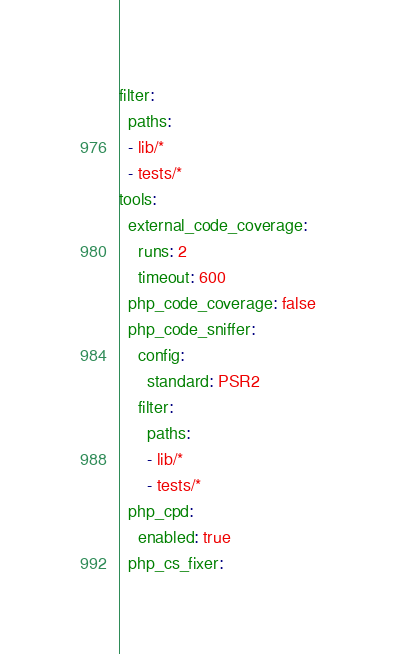Convert code to text. <code><loc_0><loc_0><loc_500><loc_500><_YAML_>filter:
  paths:
  - lib/*
  - tests/*
tools:
  external_code_coverage:
    runs: 2
    timeout: 600
  php_code_coverage: false
  php_code_sniffer:
    config:
      standard: PSR2
    filter:
      paths:
      - lib/*
      - tests/*
  php_cpd:
    enabled: true
  php_cs_fixer:</code> 